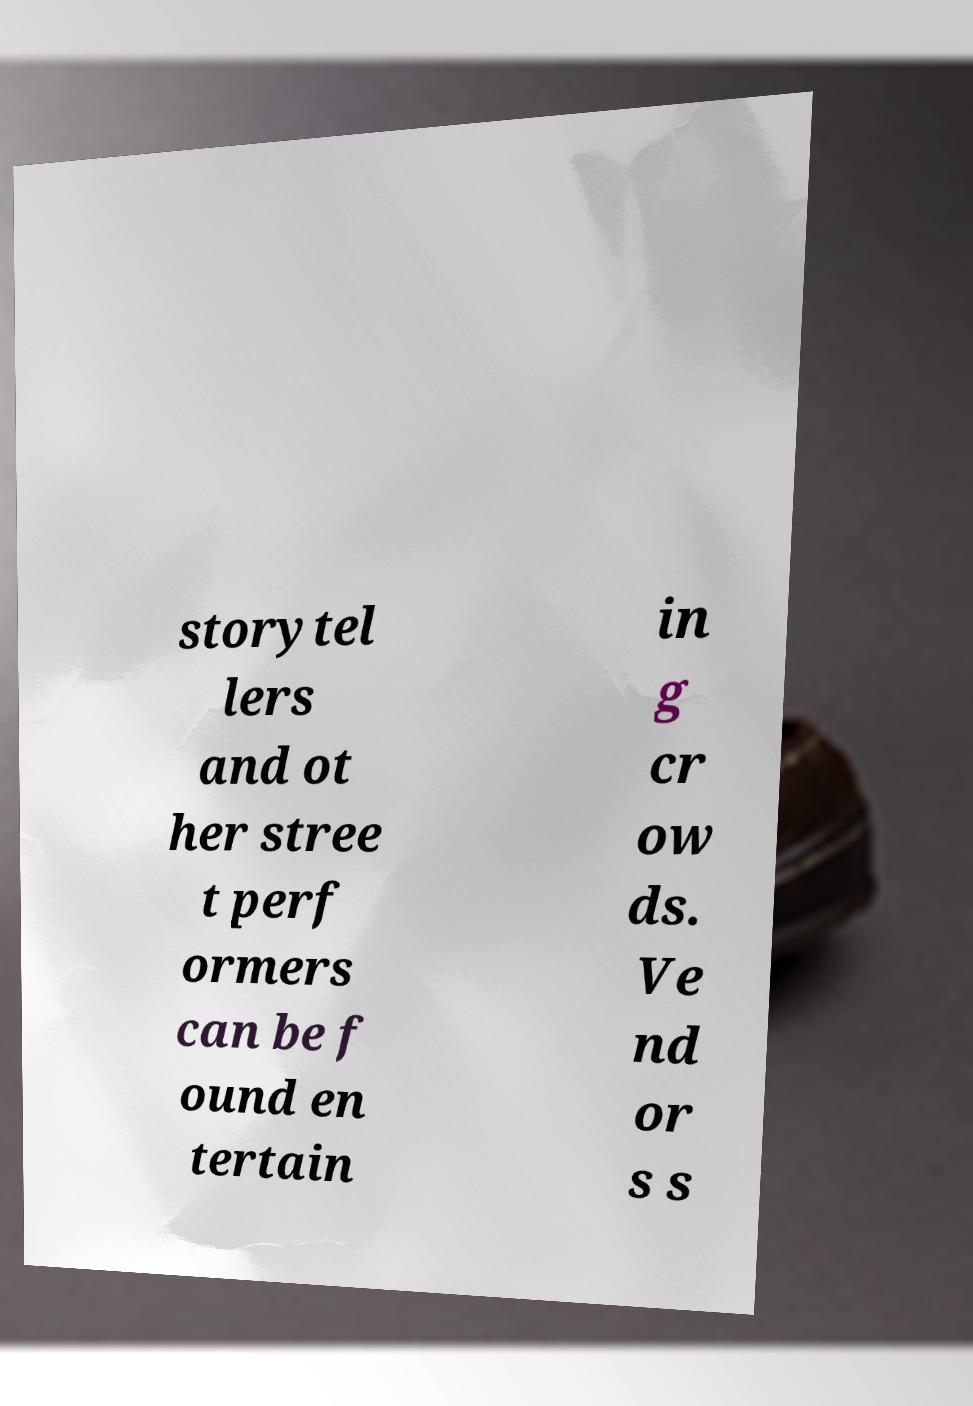Please identify and transcribe the text found in this image. storytel lers and ot her stree t perf ormers can be f ound en tertain in g cr ow ds. Ve nd or s s 